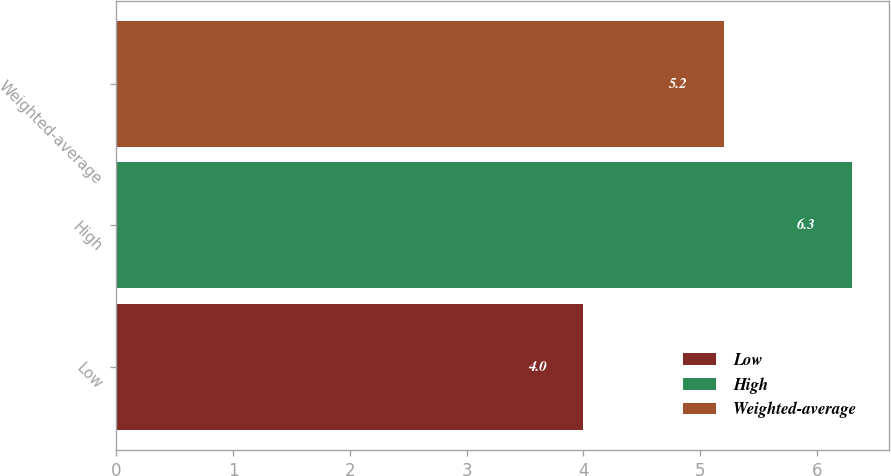Convert chart to OTSL. <chart><loc_0><loc_0><loc_500><loc_500><bar_chart><fcel>Low<fcel>High<fcel>Weighted-average<nl><fcel>4<fcel>6.3<fcel>5.2<nl></chart> 